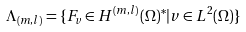Convert formula to latex. <formula><loc_0><loc_0><loc_500><loc_500>\Lambda _ { ( m , l ) } = \{ F _ { v } \in H ^ { ( m , l ) } ( \Omega ) ^ { * } | v \in L ^ { 2 } ( \Omega ) \}</formula> 